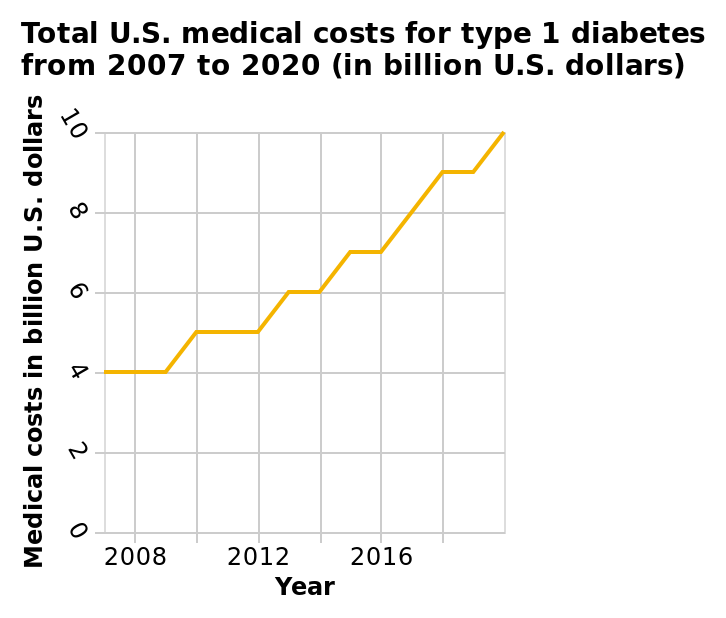<image>
Was there any stabilization period in the costs between 2016 and 2018? No, there was no period of stabilization in the costs between 2016 and 2018. What is the variable represented on the y-axis of the line chart? The y-axis of the line chart represents the medical costs in billion U.S. dollars. 